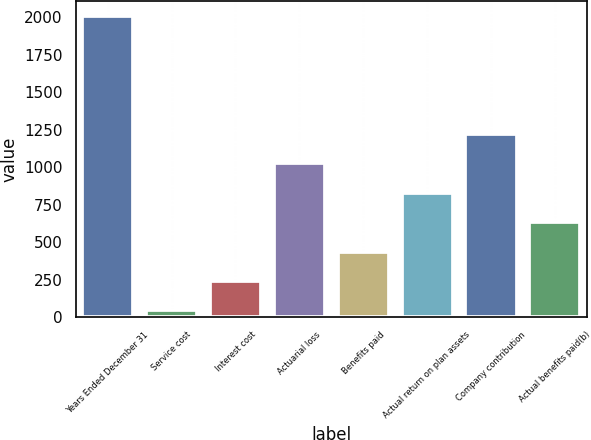<chart> <loc_0><loc_0><loc_500><loc_500><bar_chart><fcel>Years Ended December 31<fcel>Service cost<fcel>Interest cost<fcel>Actuarial loss<fcel>Benefits paid<fcel>Actual return on plan assets<fcel>Company contribution<fcel>Actual benefits paid(b)<nl><fcel>2010<fcel>44<fcel>240.6<fcel>1027<fcel>437.2<fcel>830.4<fcel>1223.6<fcel>633.8<nl></chart> 